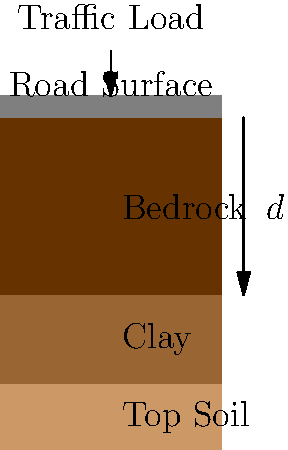As a road contractor, you're tasked with determining the required depth ($d$) of a road foundation. The soil composition consists of a 30 cm layer of top soil, followed by a 40 cm layer of clay, and then bedrock. The expected traffic load is 80 kN/m². Given that the bearing capacity of clay is 200 kPa and a safety factor of 2.5 is required, calculate the minimum depth of the road foundation needed to reach the clay layer. Assume the road surface thickness is negligible. To determine the required depth of the road foundation, we'll follow these steps:

1) First, we need to convert the traffic load from kN/m² to kPa:
   80 kN/m² = 80 kPa

2) Apply the safety factor to the traffic load:
   $80 \text{ kPa} \times 2.5 = 200 \text{ kPa}$

3) Compare this value with the bearing capacity of clay:
   Required capacity: 200 kPa
   Clay bearing capacity: 200 kPa

   Since these values are equal, we need to reach the clay layer for adequate support.

4) Calculate the depth to reach the clay layer:
   Depth of top soil = 30 cm

Therefore, the minimum depth of the road foundation should be 30 cm to reach the clay layer, which has sufficient bearing capacity to support the expected traffic load with the required safety factor.
Answer: 30 cm 